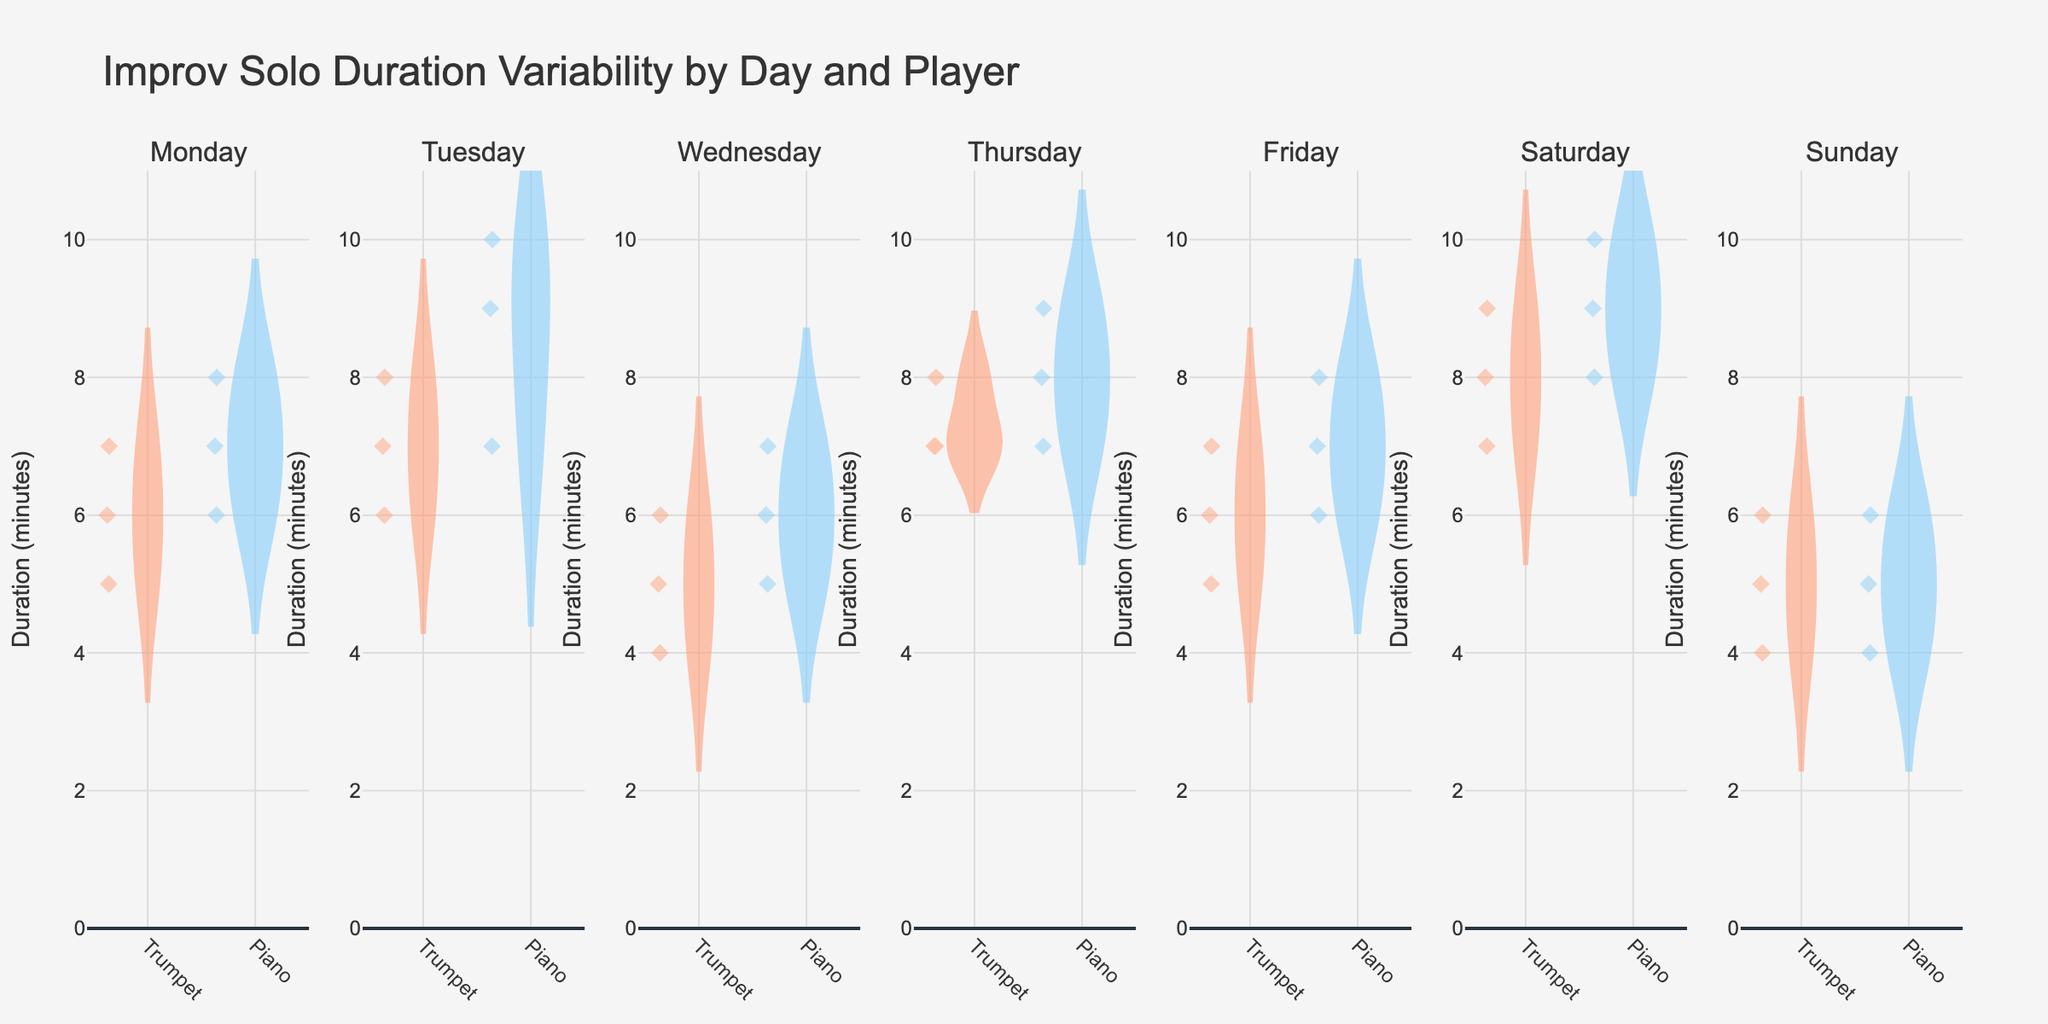What's the title of the figure? The title is generally located at the top of the figure and describes the content of the plot.
Answer: Improv Solo Duration Variability by Day and Player Which day shows the highest median duration for trumpet solos? On a violin plot, the median is typically indicated by a horizontal line within the distribution.
Answer: Saturday How does the average piano solo duration on Tuesday compare to that on Wednesday? The average duration can be estimated by the position of the mean line in the violin plot. The average for Tuesday looks higher than Wednesday.
Answer: Higher on Tuesday Which day has the greatest variability in trumpet solo durations? Variability in violin plots can be assessed by the width and spread of the plot. The day with the widest spread for trumpet solos shows the greatest variability.
Answer: Saturday What's the range of piano solo durations on Sunday? The range can be found by looking at the lowest and highest points of the piano distribution on Sunday's subplot.
Answer: 4 to 6 minutes Do any days show the same median duration for both trumpet and piano solos? We need to look for days where the horizontal lines representing the median in the violin plots for trumpet and piano are aligned.
Answer: Yes, Monday Which player shows more consistency in their solo durations across all days? Consistency is reflected in narrower and more concentrated violin plots. By comparing widths, the piano player appears more consistent.
Answer: Piano On which day are all the trumpet solos below 6 minutes? We need to identify the day where the upper endpoint of all the violin plots for trumpet solos is less than 6 minutes.
Answer: Wednesday What is the mean duration of the piano solos on Friday? The mean duration is indicated by the vertical line in the piano violin plot for Friday.
Answer: Approximately 7 minutes How does the variability in durations of trumpet solos on Monday compare to Thursday? To compare variability, examine the width and spread of the violin plots for trumpet solos on both days. Monday shows less variability than Thursday.
Answer: Less on Monday 